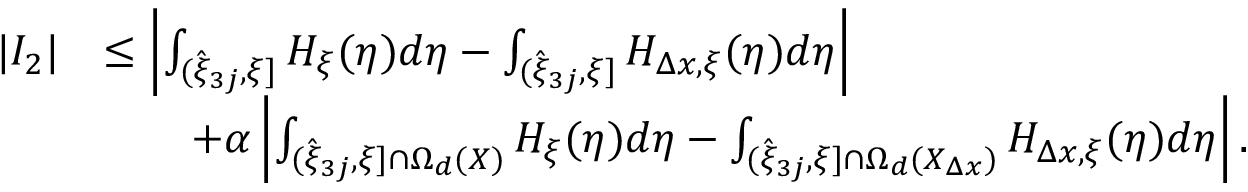<formula> <loc_0><loc_0><loc_500><loc_500>\begin{array} { r l } { | I _ { 2 } | } & { \leq \left | \int _ { ( \hat { \xi } _ { 3 j } , \xi ] } H _ { \xi } ( \eta ) d \eta - \int _ { ( \hat { \xi } _ { 3 j } , \xi ] } H _ { \Delta x , \xi } ( \eta ) d \eta \right | } \\ & { \quad + \alpha \left | \int _ { ( \hat { \xi } _ { 3 j } , \xi ] \cap \Omega _ { d } ( X ) } H _ { \xi } ( \eta ) d \eta - \int _ { ( \hat { \xi } _ { 3 j } , \xi ] \cap \Omega _ { d } ( X _ { \Delta x } ) } H _ { \Delta x , \xi } ( \eta ) d \eta \right | . } \end{array}</formula> 